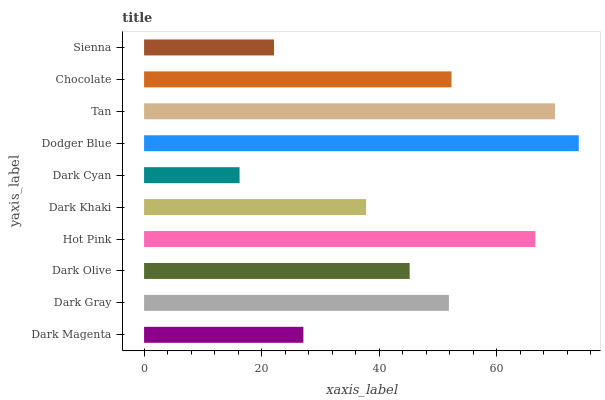Is Dark Cyan the minimum?
Answer yes or no. Yes. Is Dodger Blue the maximum?
Answer yes or no. Yes. Is Dark Gray the minimum?
Answer yes or no. No. Is Dark Gray the maximum?
Answer yes or no. No. Is Dark Gray greater than Dark Magenta?
Answer yes or no. Yes. Is Dark Magenta less than Dark Gray?
Answer yes or no. Yes. Is Dark Magenta greater than Dark Gray?
Answer yes or no. No. Is Dark Gray less than Dark Magenta?
Answer yes or no. No. Is Dark Gray the high median?
Answer yes or no. Yes. Is Dark Olive the low median?
Answer yes or no. Yes. Is Dark Khaki the high median?
Answer yes or no. No. Is Hot Pink the low median?
Answer yes or no. No. 